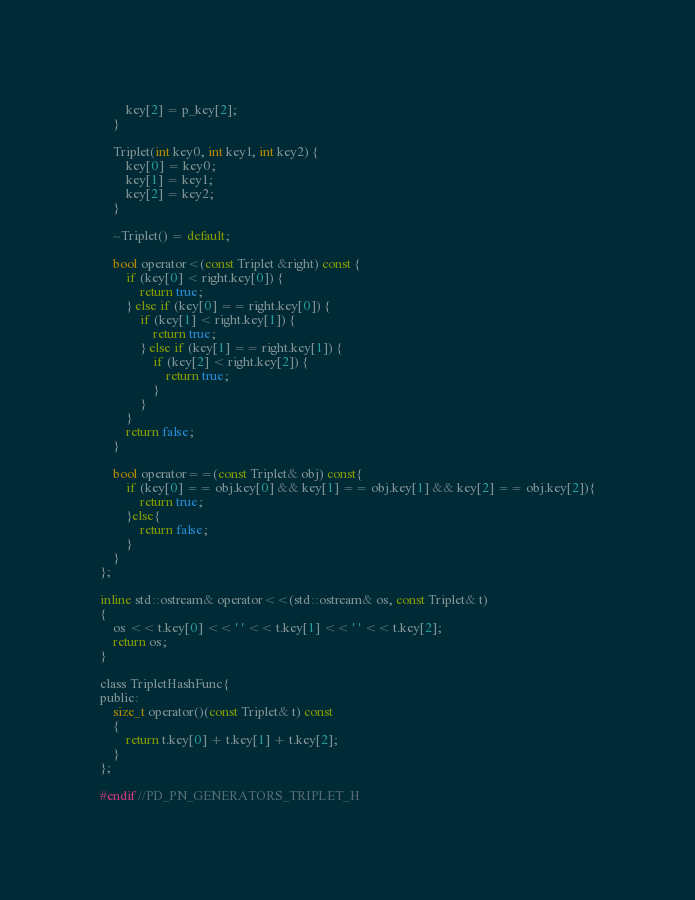Convert code to text. <code><loc_0><loc_0><loc_500><loc_500><_C_>        key[2] = p_key[2];
    }

    Triplet(int key0, int key1, int key2) {
        key[0] = key0;
        key[1] = key1;
        key[2] = key2;
    }

    ~Triplet() = default;

    bool operator<(const Triplet &right) const {
        if (key[0] < right.key[0]) {
            return true;
        } else if (key[0] == right.key[0]) {
            if (key[1] < right.key[1]) {
                return true;
            } else if (key[1] == right.key[1]) {
                if (key[2] < right.key[2]) {
                    return true;
                }
            }
        }
        return false;
    }

    bool operator==(const Triplet& obj) const{
        if (key[0] == obj.key[0] && key[1] == obj.key[1] && key[2] == obj.key[2]){
            return true;
        }else{
            return false;
        }
    }
};

inline std::ostream& operator<<(std::ostream& os, const Triplet& t)
{
    os << t.key[0] << ' ' << t.key[1] << ' ' << t.key[2];
    return os;
}

class TripletHashFunc{
public:
    size_t operator()(const Triplet& t) const
    {
        return t.key[0] + t.key[1] + t.key[2];
    }
};

#endif //PD_PN_GENERATORS_TRIPLET_H
</code> 